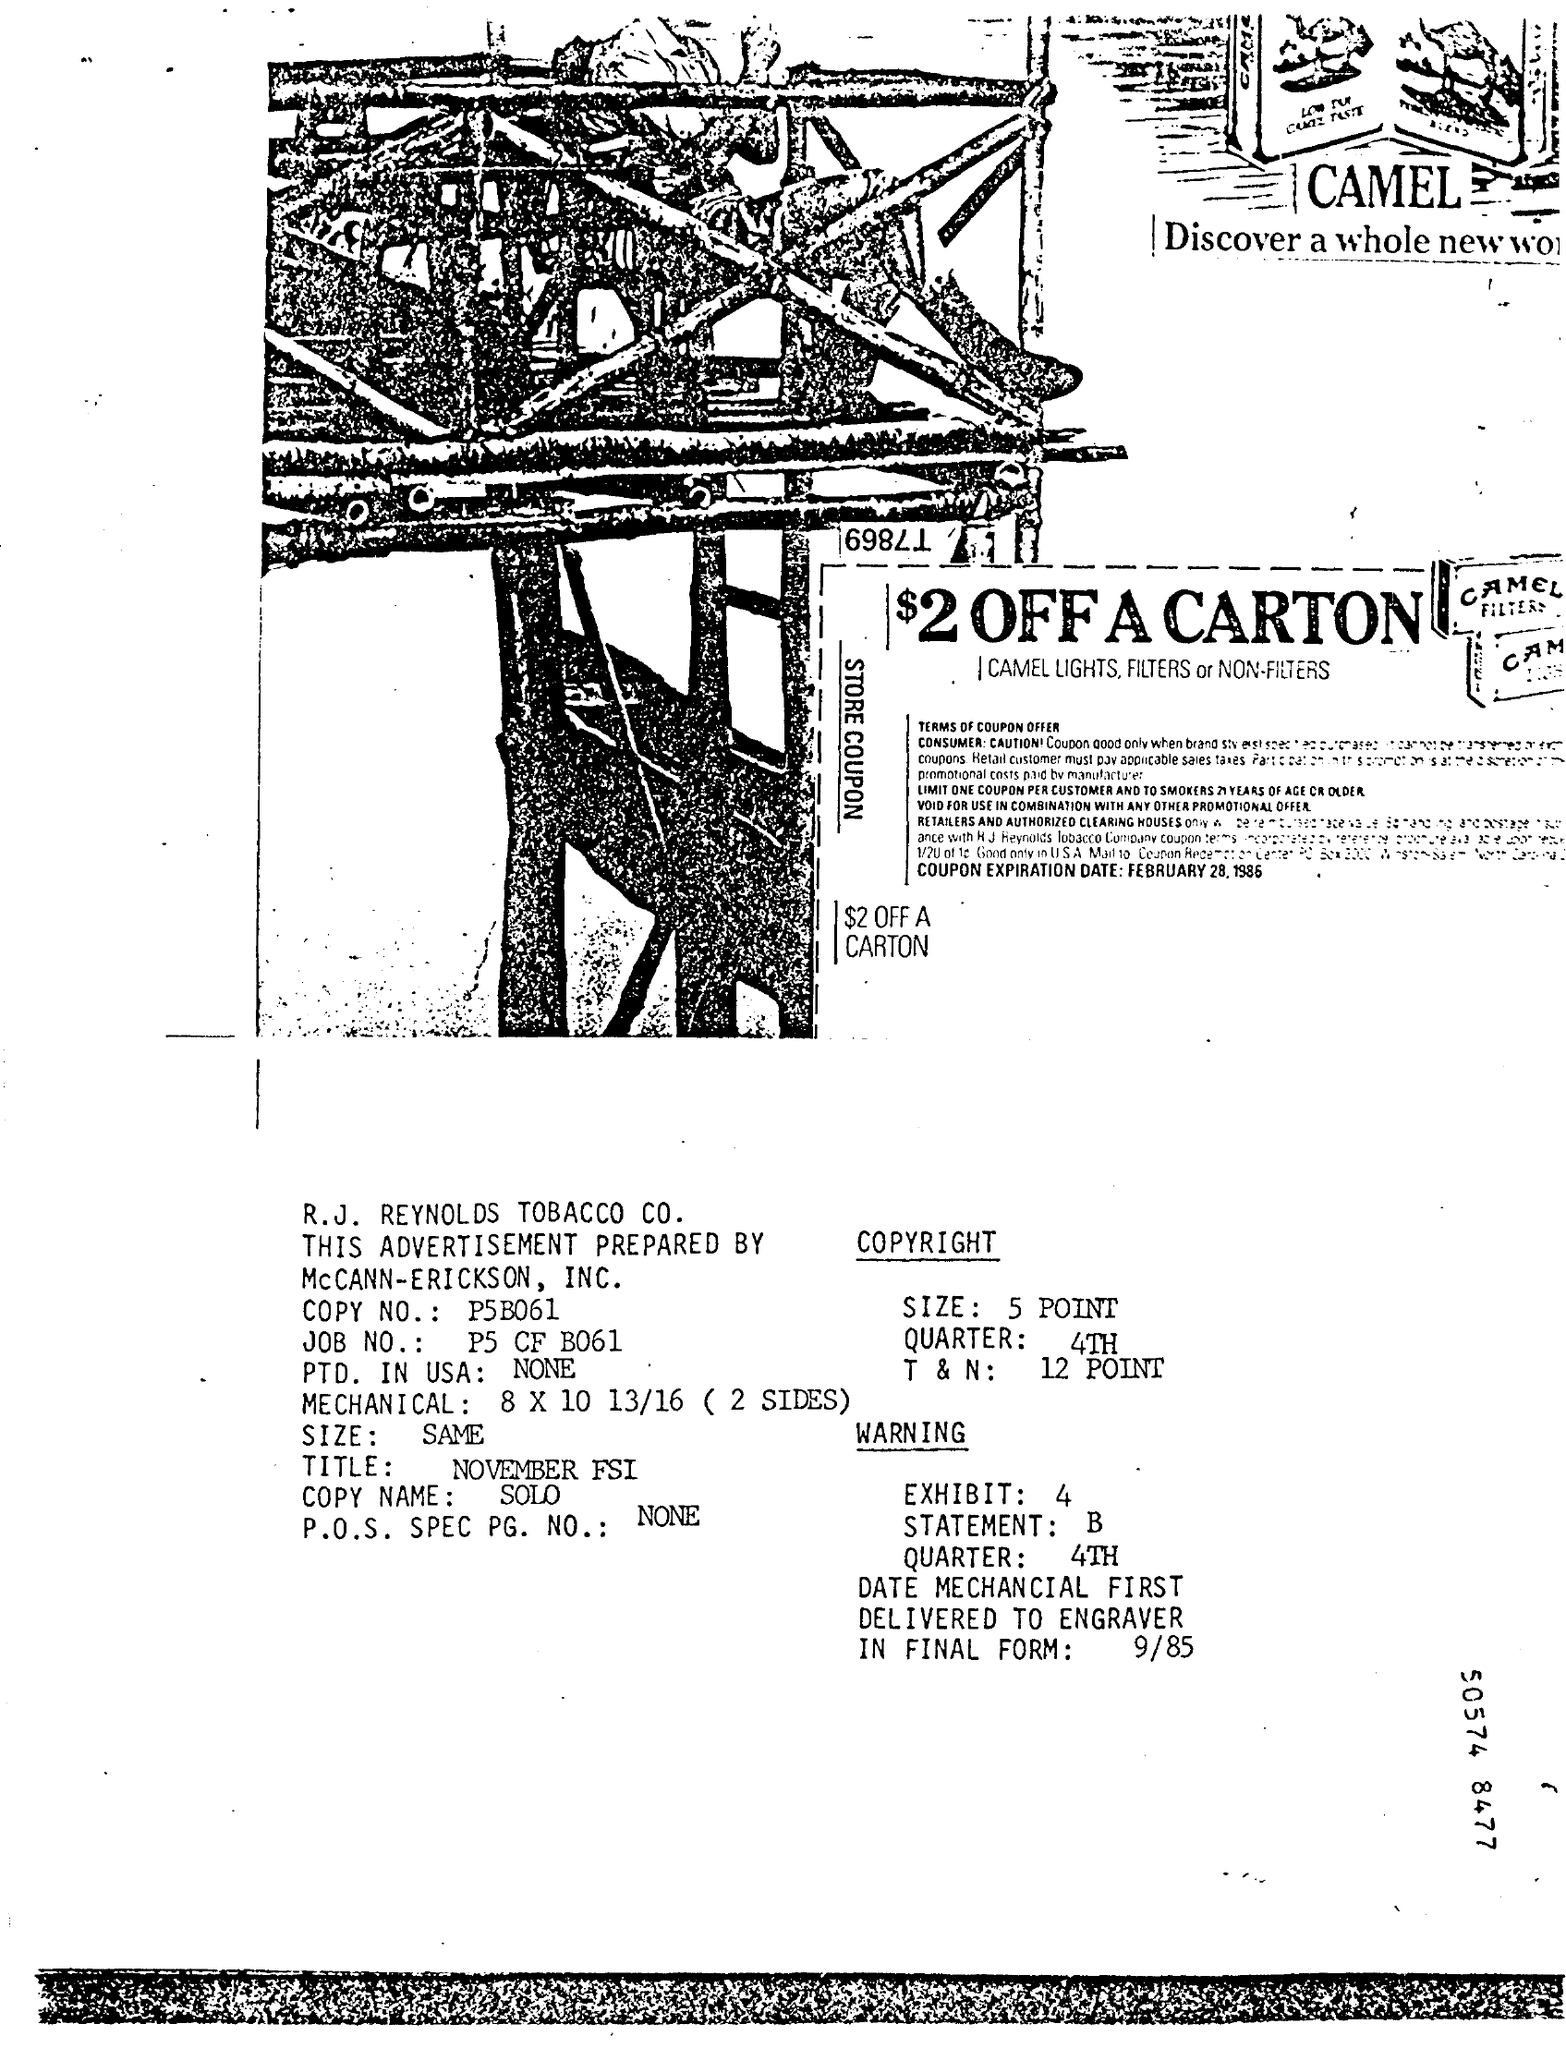Draw attention to some important aspects in this diagram. The advertisement was prepared by McCANN-ERICKSON, INC. For a limited time, customers can enjoy a discount of $2 off any carton purchased at the store. The promotion includes the following products: CAMEL LIGHTS, FILTERS, and NON-FILTERS. 